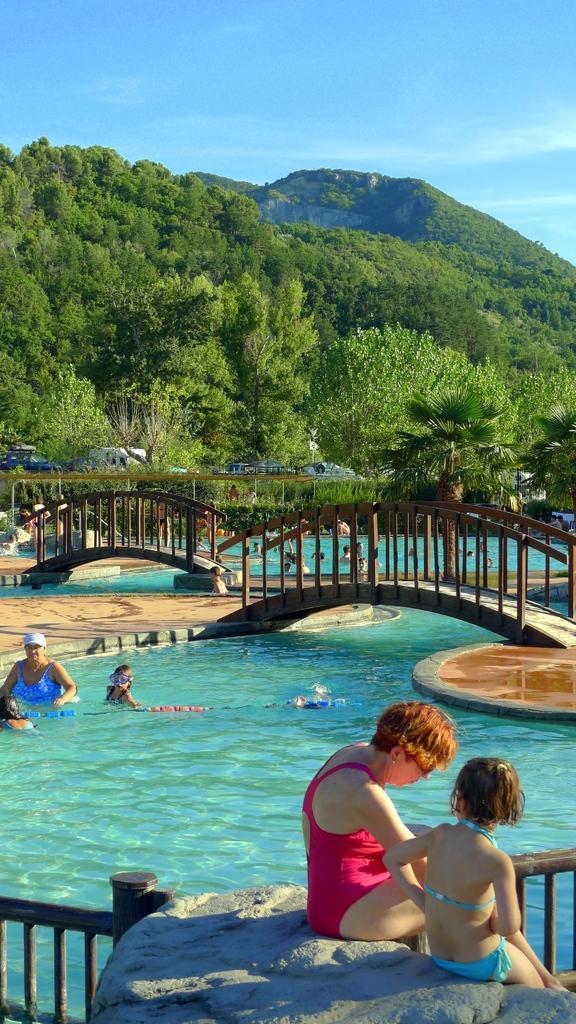Please provide a concise description of this image. In this picture I can see a woman and a girl sitting in front on a rock and in the middle of this picture I can see the swimming pool and I see number of people in it and I can see the bridges. In the background I can see number of trees and I can see the clear sky. 